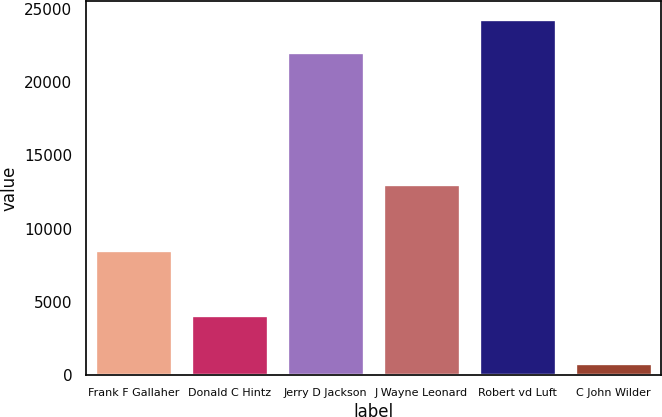Convert chart. <chart><loc_0><loc_0><loc_500><loc_500><bar_chart><fcel>Frank F Gallaher<fcel>Donald C Hintz<fcel>Jerry D Jackson<fcel>J Wayne Leonard<fcel>Robert vd Luft<fcel>C John Wilder<nl><fcel>8519<fcel>4055<fcel>22083<fcel>13065<fcel>24330.4<fcel>798<nl></chart> 